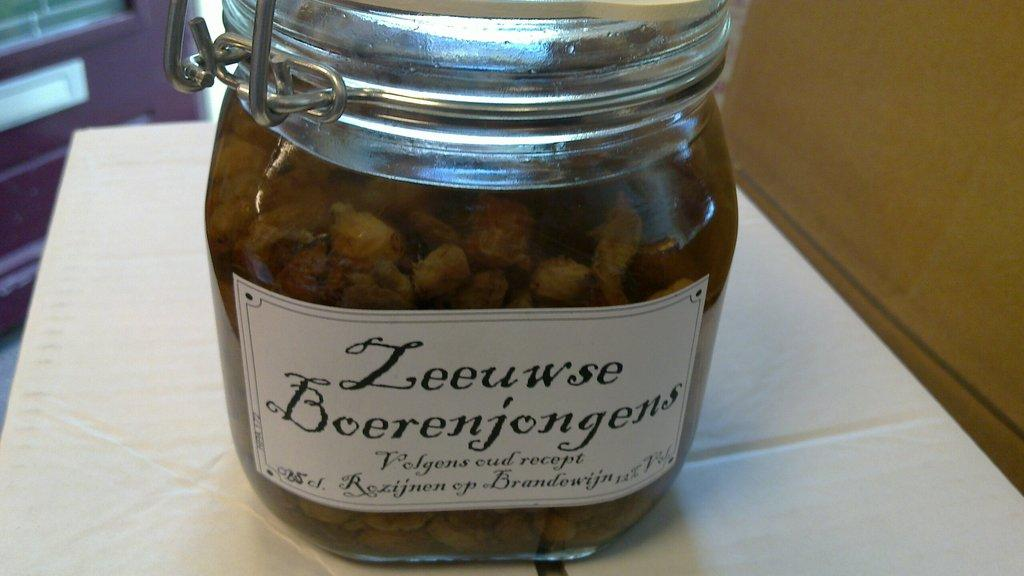<image>
Write a terse but informative summary of the picture. Glass jar with a white sticker on it titled "Leeuwse Boerenjongens". 